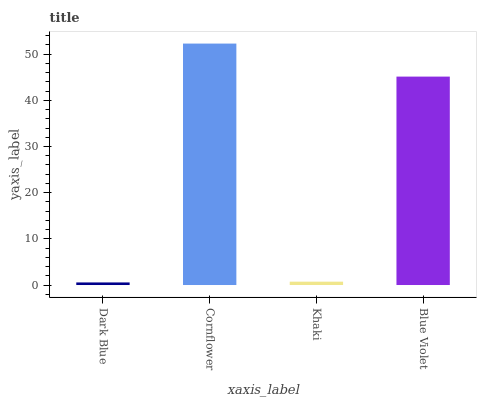Is Dark Blue the minimum?
Answer yes or no. Yes. Is Cornflower the maximum?
Answer yes or no. Yes. Is Khaki the minimum?
Answer yes or no. No. Is Khaki the maximum?
Answer yes or no. No. Is Cornflower greater than Khaki?
Answer yes or no. Yes. Is Khaki less than Cornflower?
Answer yes or no. Yes. Is Khaki greater than Cornflower?
Answer yes or no. No. Is Cornflower less than Khaki?
Answer yes or no. No. Is Blue Violet the high median?
Answer yes or no. Yes. Is Khaki the low median?
Answer yes or no. Yes. Is Dark Blue the high median?
Answer yes or no. No. Is Cornflower the low median?
Answer yes or no. No. 